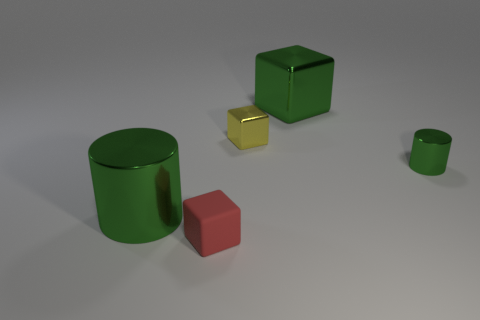How big is the red thing?
Offer a very short reply. Small. What is the shape of the tiny green object?
Keep it short and to the point. Cylinder. Do the yellow object and the green shiny thing behind the yellow object have the same shape?
Your response must be concise. Yes. There is a big green thing to the right of the tiny red object; does it have the same shape as the small red rubber object?
Provide a short and direct response. Yes. How many small metal things are left of the tiny green thing and in front of the yellow metallic object?
Offer a very short reply. 0. How many other things are there of the same size as the yellow metal cube?
Offer a very short reply. 2. Is the number of tiny green objects that are to the left of the tiny cylinder the same as the number of green cylinders?
Keep it short and to the point. No. Do the large cylinder that is in front of the big green shiny block and the metallic cylinder to the right of the red block have the same color?
Your answer should be very brief. Yes. There is a green object that is both in front of the big green shiny block and on the right side of the large green cylinder; what material is it made of?
Provide a succinct answer. Metal. The small metal cube has what color?
Provide a succinct answer. Yellow. 